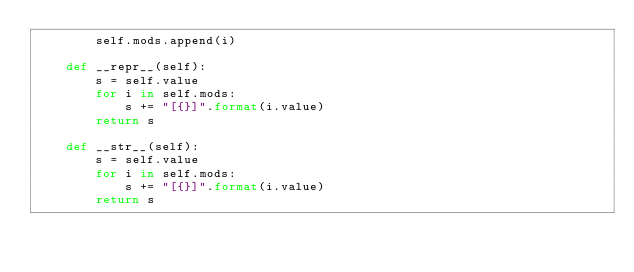Convert code to text. <code><loc_0><loc_0><loc_500><loc_500><_Python_>        self.mods.append(i)

    def __repr__(self):
        s = self.value
        for i in self.mods:
            s += "[{}]".format(i.value)
        return s

    def __str__(self):
        s = self.value
        for i in self.mods:
            s += "[{}]".format(i.value)
        return s


</code> 